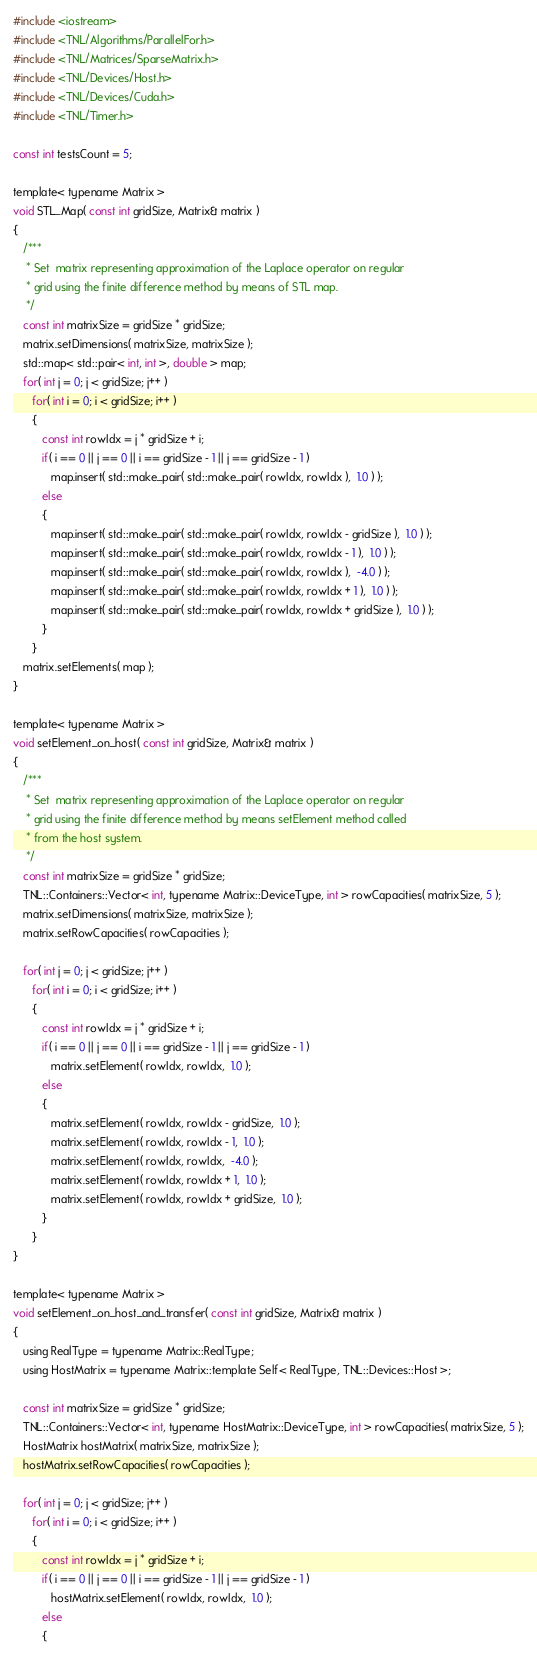Convert code to text. <code><loc_0><loc_0><loc_500><loc_500><_Cuda_>#include <iostream>
#include <TNL/Algorithms/ParallelFor.h>
#include <TNL/Matrices/SparseMatrix.h>
#include <TNL/Devices/Host.h>
#include <TNL/Devices/Cuda.h>
#include <TNL/Timer.h>

const int testsCount = 5;

template< typename Matrix >
void STL_Map( const int gridSize, Matrix& matrix )
{
   /***
    * Set  matrix representing approximation of the Laplace operator on regular
    * grid using the finite difference method by means of STL map.
    */
   const int matrixSize = gridSize * gridSize;
   matrix.setDimensions( matrixSize, matrixSize );
   std::map< std::pair< int, int >, double > map;
   for( int j = 0; j < gridSize; j++ )
      for( int i = 0; i < gridSize; i++ )
      {
         const int rowIdx = j * gridSize + i;
         if( i == 0 || j == 0 || i == gridSize - 1 || j == gridSize - 1 )
            map.insert( std::make_pair( std::make_pair( rowIdx, rowIdx ),  1.0 ) );
         else
         {
            map.insert( std::make_pair( std::make_pair( rowIdx, rowIdx - gridSize ),  1.0 ) );
            map.insert( std::make_pair( std::make_pair( rowIdx, rowIdx - 1 ),  1.0 ) );
            map.insert( std::make_pair( std::make_pair( rowIdx, rowIdx ),  -4.0 ) );
            map.insert( std::make_pair( std::make_pair( rowIdx, rowIdx + 1 ),  1.0 ) );
            map.insert( std::make_pair( std::make_pair( rowIdx, rowIdx + gridSize ),  1.0 ) );
         }
      }
   matrix.setElements( map );
}

template< typename Matrix >
void setElement_on_host( const int gridSize, Matrix& matrix )
{
   /***
    * Set  matrix representing approximation of the Laplace operator on regular
    * grid using the finite difference method by means setElement method called
    * from the host system.
    */
   const int matrixSize = gridSize * gridSize;
   TNL::Containers::Vector< int, typename Matrix::DeviceType, int > rowCapacities( matrixSize, 5 );
   matrix.setDimensions( matrixSize, matrixSize );
   matrix.setRowCapacities( rowCapacities );

   for( int j = 0; j < gridSize; j++ )
      for( int i = 0; i < gridSize; i++ )
      {
         const int rowIdx = j * gridSize + i;
         if( i == 0 || j == 0 || i == gridSize - 1 || j == gridSize - 1 )
            matrix.setElement( rowIdx, rowIdx,  1.0 );
         else
         {
            matrix.setElement( rowIdx, rowIdx - gridSize,  1.0 );
            matrix.setElement( rowIdx, rowIdx - 1,  1.0 );
            matrix.setElement( rowIdx, rowIdx,  -4.0 );
            matrix.setElement( rowIdx, rowIdx + 1,  1.0 );
            matrix.setElement( rowIdx, rowIdx + gridSize,  1.0 );
         }
      }
}

template< typename Matrix >
void setElement_on_host_and_transfer( const int gridSize, Matrix& matrix )
{
   using RealType = typename Matrix::RealType;
   using HostMatrix = typename Matrix::template Self< RealType, TNL::Devices::Host >;

   const int matrixSize = gridSize * gridSize;
   TNL::Containers::Vector< int, typename HostMatrix::DeviceType, int > rowCapacities( matrixSize, 5 );
   HostMatrix hostMatrix( matrixSize, matrixSize );
   hostMatrix.setRowCapacities( rowCapacities );

   for( int j = 0; j < gridSize; j++ )
      for( int i = 0; i < gridSize; i++ )
      {
         const int rowIdx = j * gridSize + i;
         if( i == 0 || j == 0 || i == gridSize - 1 || j == gridSize - 1 )
            hostMatrix.setElement( rowIdx, rowIdx,  1.0 );
         else
         {</code> 